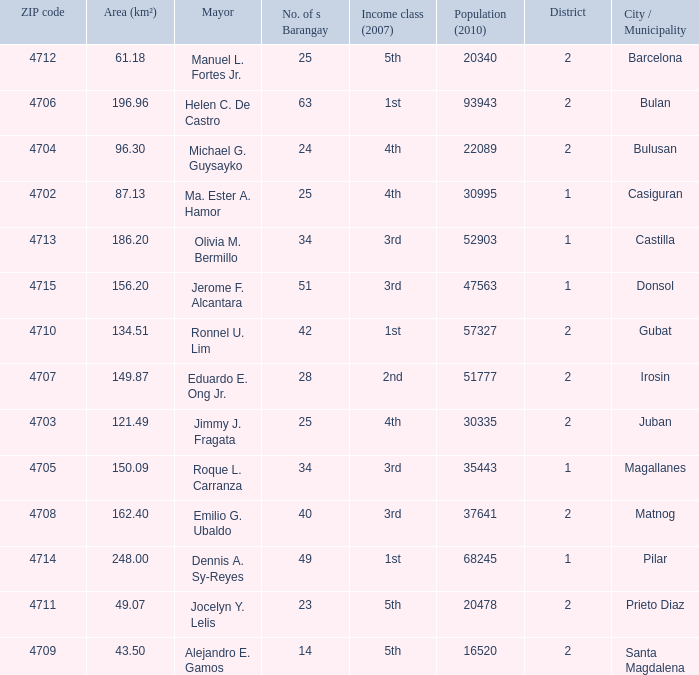What is the total quantity of populace (2010) where location (km²) is 134.51 1.0. 